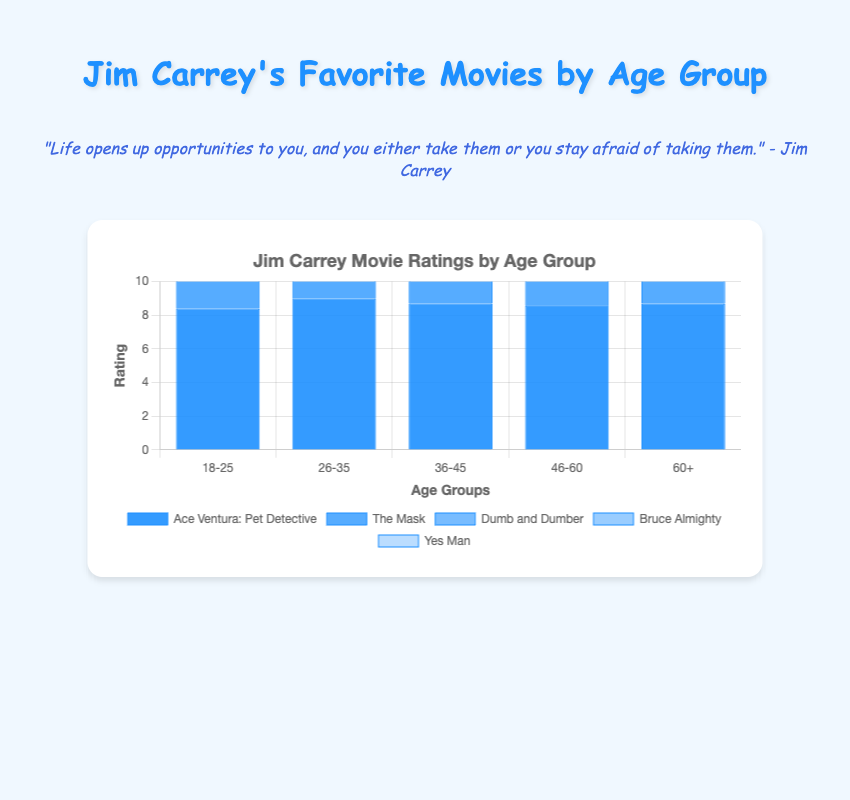Which movie has the highest rating among the 18-25 age group? Looking at the bars for the 18-25 age group, "Ace Ventura: Pet Detective" has the highest rating at 8.4.
Answer: Ace Ventura: Pet Detective How does the rating of "The Mask" compare between the 18-25 and 36-45 age groups? In the 18-25 age group, "The Mask" has a rating of 8.1. In the 36-45 age group, its rating is 8.7. Therefore, "The Mask" is rated higher by the 36-45 age group.
Answer: Higher in the 36-45 age group What is the average rating for "The Truman Show" across all age groups? The ratings for "The Truman Show" are 8.9, 8.6, 8.6, and 8.7. Adding these together (8.9 + 8.6 + 8.6 + 8.7) gives 34.8, and dividing by the number of age groups (4) gives the average rating of 8.7.
Answer: 8.7 Which age group rated "Man on the Moon" the highest? Observing the bars for "Man on the Moon," the 36-45 age group rated it 8.4, the highest compared to the other age groups.
Answer: 36-45 Compare the rating of "Bruce Almighty" between the 18-25 and 60+ age groups. Which age group rated it higher? "Bruce Almighty" has a rating of 8.0 in the 18-25 age group and 8.1 in the 60+ age group. Thus, the 60+ age group rated it higher.
Answer: 60+ What is the total sum of ratings for "Liar Liar" across all age groups? The ratings for "Liar Liar" are 8.4, 8.2, 8.1, and 8.0. Adding these together (8.4 + 8.2 + 8.1 + 8.0) results in a total sum of 32.7.
Answer: 32.7 Which movie has the most consistent ratings across different age groups? "The Truman Show" has ratings of 8.9, 8.6, 8.6, and 8.7, showing very little variation across age groups. This consistency is higher than other movies like "The Mask" and "Liar Liar," which have more fluctuating ratings.
Answer: The Truman Show 